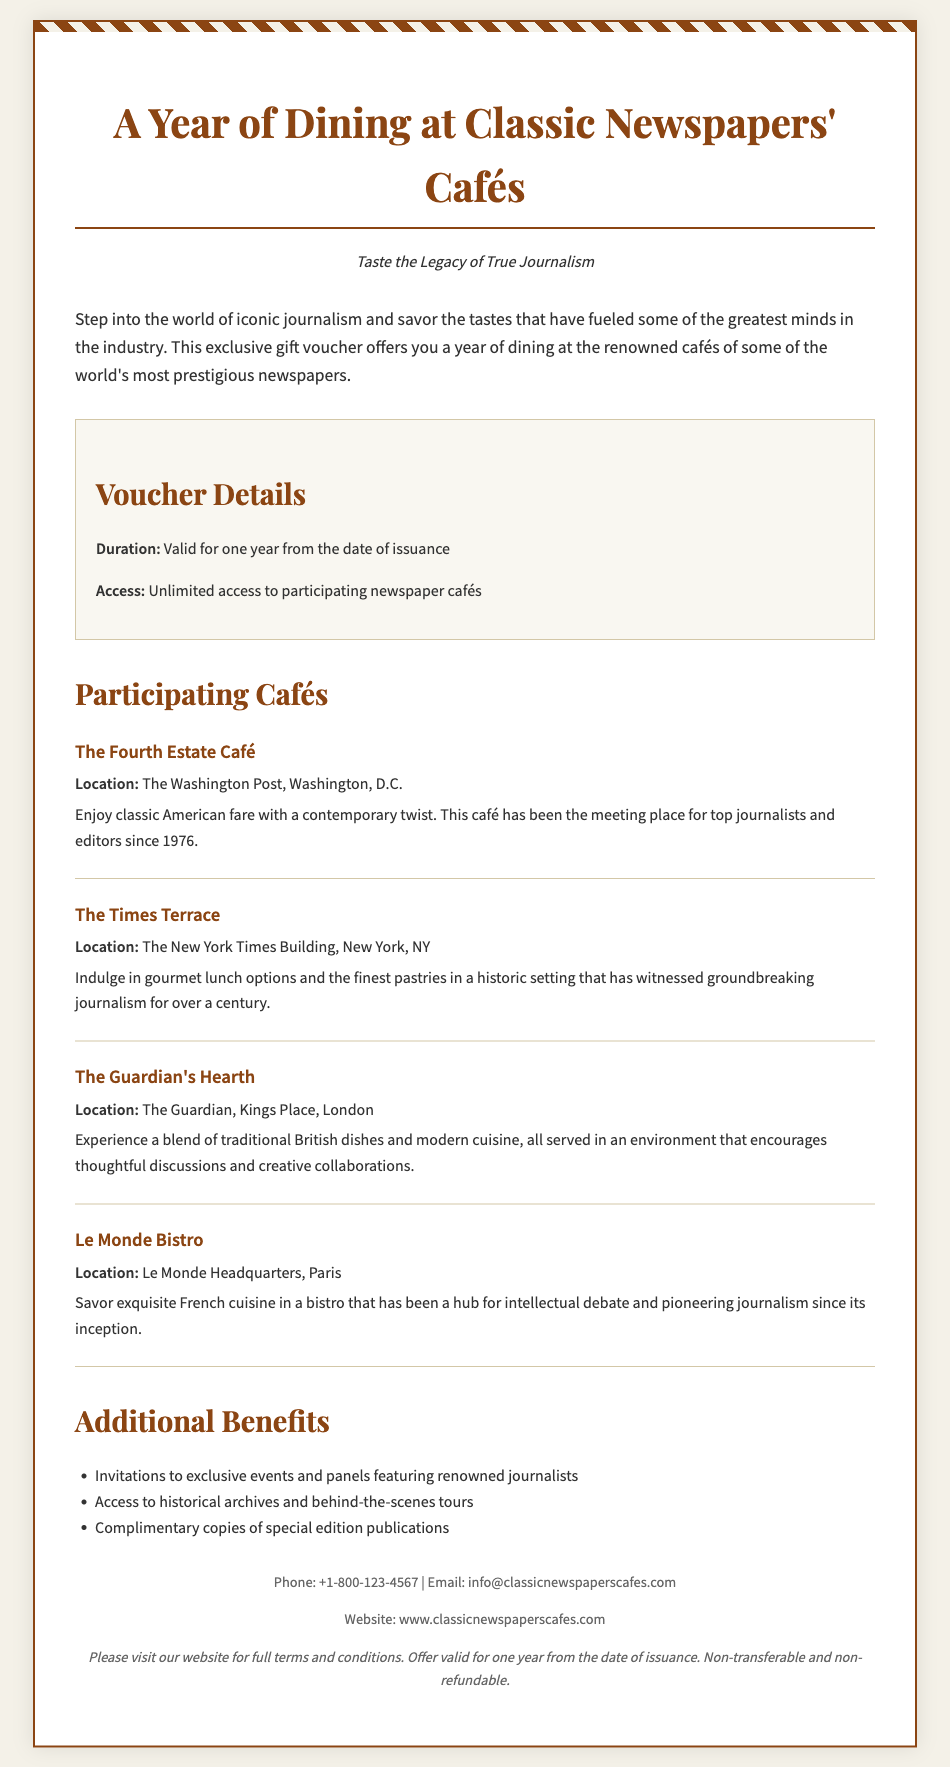What is the duration of the voucher? The document states that the voucher is valid for one year from the date of issuance.
Answer: One year How many participating cafés are listed? The document lists four participating cafés which are detailed in the sections.
Answer: Four What is the name of the café at The Washington Post? The document mentions "The Fourth Estate Café" as the café located at The Washington Post.
Answer: The Fourth Estate Café What additional benefit includes access to special events? The document indicates that there are invitations to exclusive events and panels featuring renowned journalists as an additional benefit.
Answer: Invitations to exclusive events What is the location of Le Monde Bistro? The document specifies that Le Monde Bistro is located at Le Monde Headquarters, Paris.
Answer: Le Monde Headquarters, Paris Which café serves modern cuisine in London? The document describes "The Guardian's Hearth" as serving a blend of traditional British dishes and modern cuisine.
Answer: The Guardian's Hearth What is the contact phone number provided? The document includes a phone number for contact which is +1-800-123-4567.
Answer: +1-800-123-4567 What type of document is this? The document is a gift voucher for dining at cafés associated with classic newspapers.
Answer: Gift voucher 